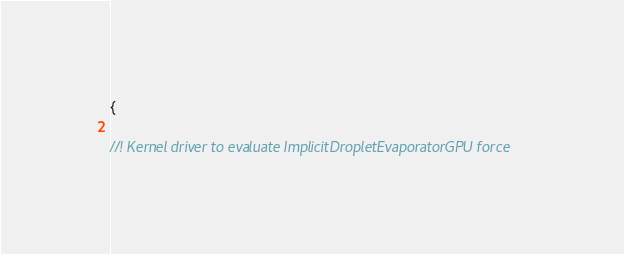<code> <loc_0><loc_0><loc_500><loc_500><_Cuda_>{

//! Kernel driver to evaluate ImplicitDropletEvaporatorGPU force</code> 